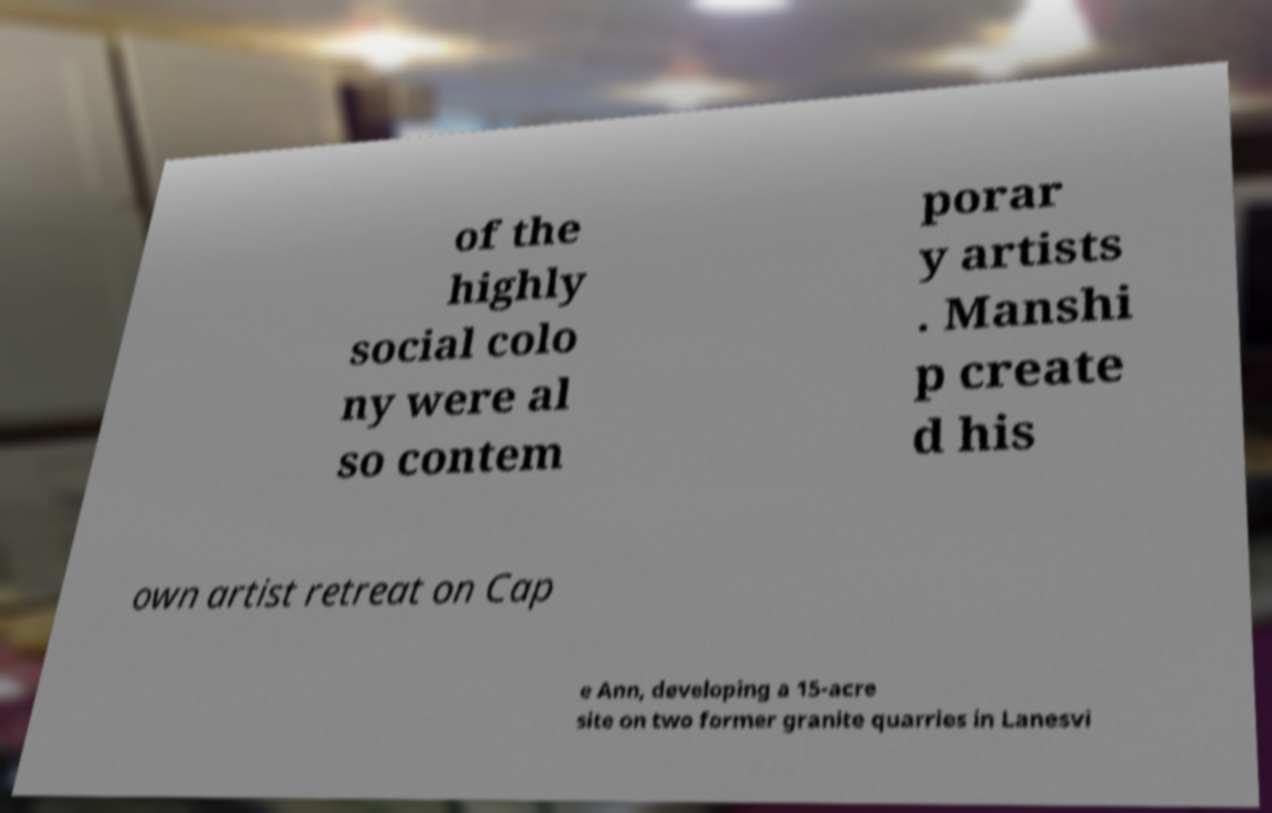Can you accurately transcribe the text from the provided image for me? of the highly social colo ny were al so contem porar y artists . Manshi p create d his own artist retreat on Cap e Ann, developing a 15-acre site on two former granite quarries in Lanesvi 